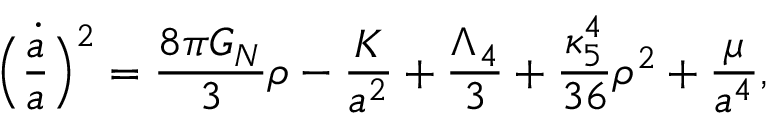<formula> <loc_0><loc_0><loc_500><loc_500>\left ( \frac { { \dot { a } } } { a } \right ) ^ { 2 } = \frac { 8 \pi G _ { N } } { 3 } \rho - \frac { K } { a ^ { 2 } } + \frac { \Lambda _ { 4 } } { 3 } + \frac { \kappa _ { 5 } ^ { 4 } } { 3 6 } \rho ^ { 2 } + \frac { \mu } { a ^ { 4 } } ,</formula> 